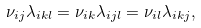<formula> <loc_0><loc_0><loc_500><loc_500>\nu _ { i j } \lambda _ { i k l } = \nu _ { i k } \lambda _ { i j l } = \nu _ { i l } \lambda _ { i k j } ,</formula> 